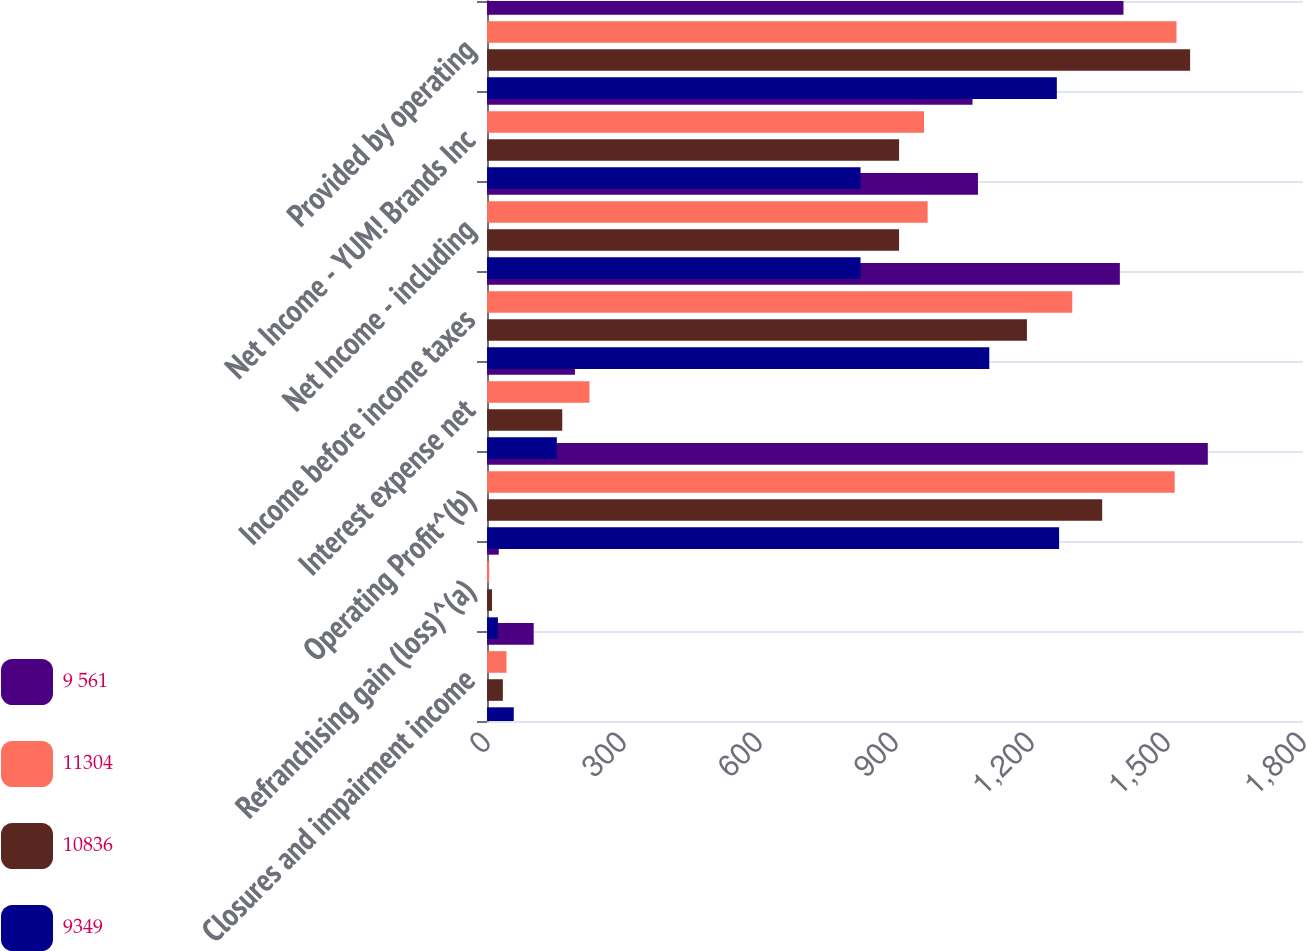<chart> <loc_0><loc_0><loc_500><loc_500><stacked_bar_chart><ecel><fcel>Closures and impairment income<fcel>Refranchising gain (loss)^(a)<fcel>Operating Profit^(b)<fcel>Interest expense net<fcel>Income before income taxes<fcel>Net Income - including<fcel>Net Income - YUM! Brands Inc<fcel>Provided by operating<nl><fcel>9 561<fcel>103<fcel>26<fcel>1590<fcel>194<fcel>1396<fcel>1083<fcel>1071<fcel>1404<nl><fcel>11304<fcel>43<fcel>5<fcel>1517<fcel>226<fcel>1291<fcel>972<fcel>964<fcel>1521<nl><fcel>10836<fcel>35<fcel>11<fcel>1357<fcel>166<fcel>1191<fcel>909<fcel>909<fcel>1551<nl><fcel>9349<fcel>59<fcel>24<fcel>1262<fcel>154<fcel>1108<fcel>824<fcel>824<fcel>1257<nl></chart> 